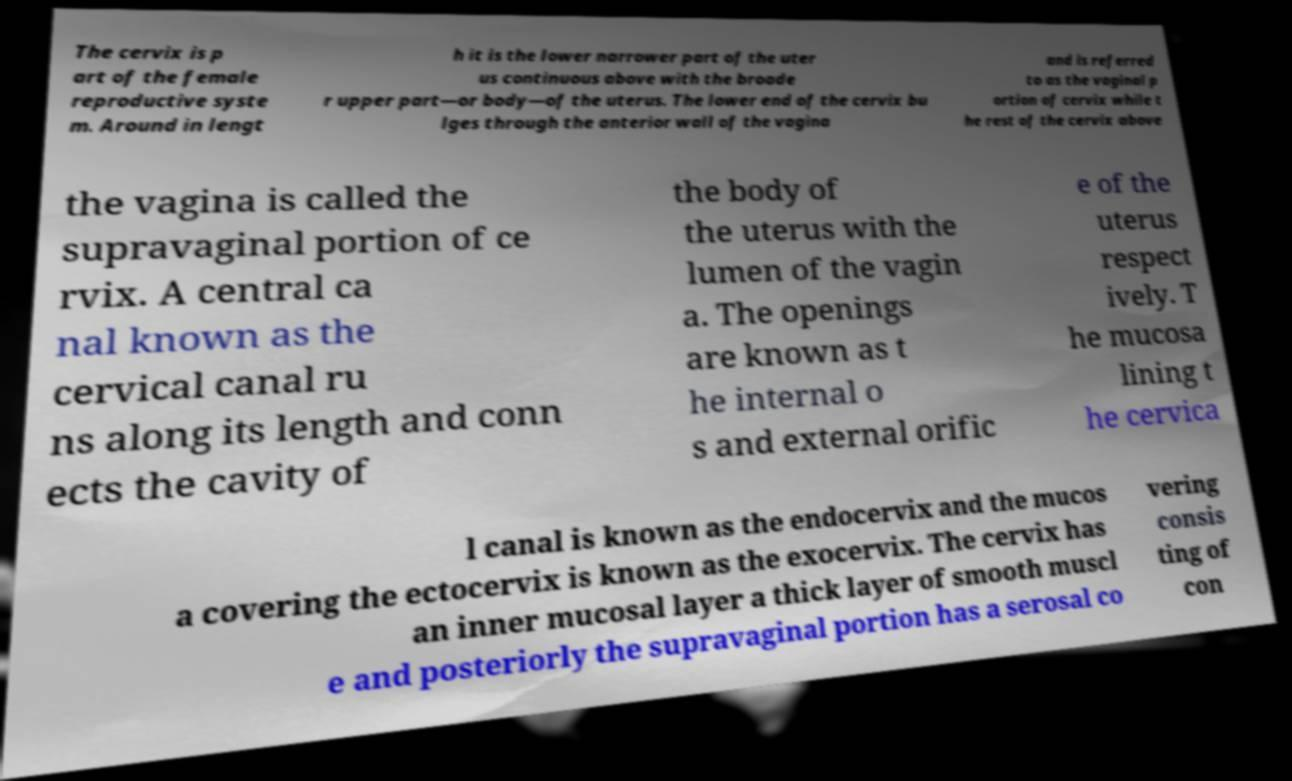Please read and relay the text visible in this image. What does it say? The cervix is p art of the female reproductive syste m. Around in lengt h it is the lower narrower part of the uter us continuous above with the broade r upper part—or body—of the uterus. The lower end of the cervix bu lges through the anterior wall of the vagina and is referred to as the vaginal p ortion of cervix while t he rest of the cervix above the vagina is called the supravaginal portion of ce rvix. A central ca nal known as the cervical canal ru ns along its length and conn ects the cavity of the body of the uterus with the lumen of the vagin a. The openings are known as t he internal o s and external orific e of the uterus respect ively. T he mucosa lining t he cervica l canal is known as the endocervix and the mucos a covering the ectocervix is known as the exocervix. The cervix has an inner mucosal layer a thick layer of smooth muscl e and posteriorly the supravaginal portion has a serosal co vering consis ting of con 